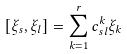<formula> <loc_0><loc_0><loc_500><loc_500>[ \xi _ { s } , \xi _ { l } ] = \sum ^ { r } _ { k = 1 } c ^ { k } _ { s l } \xi _ { k }</formula> 